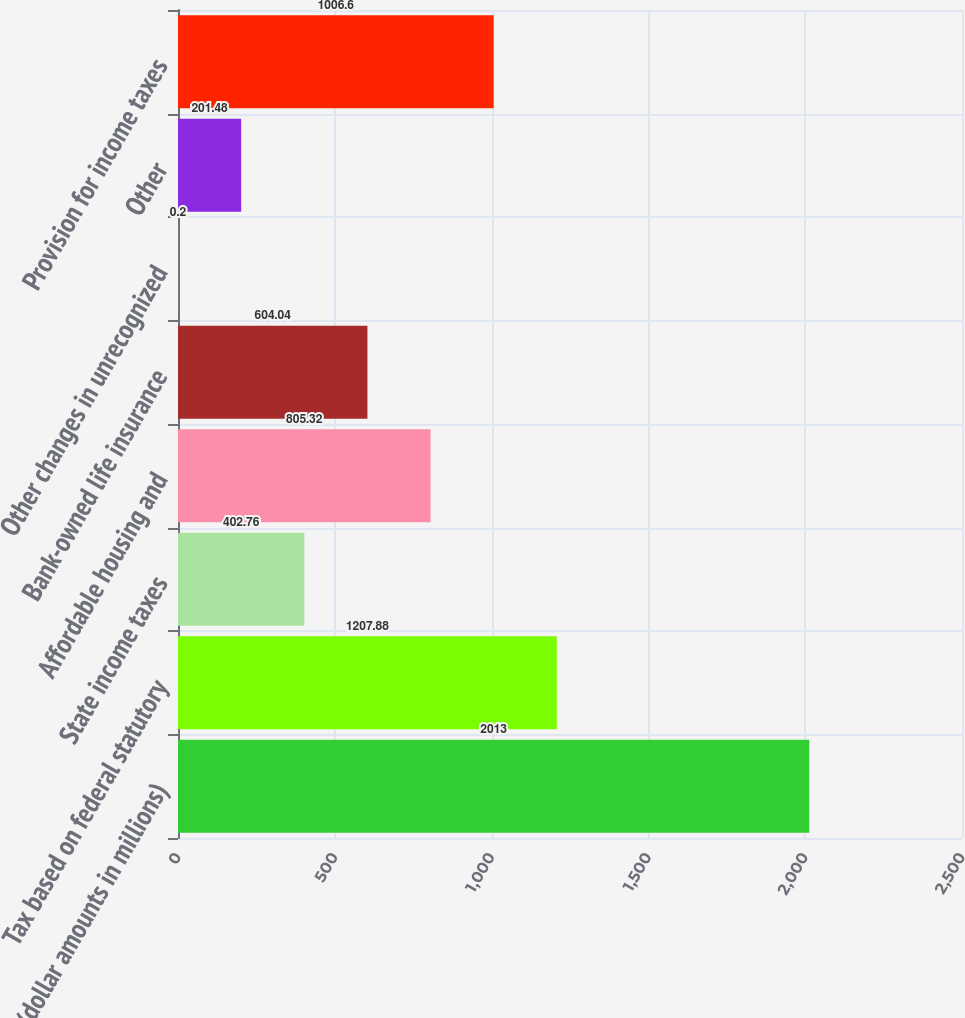Convert chart to OTSL. <chart><loc_0><loc_0><loc_500><loc_500><bar_chart><fcel>(dollar amounts in millions)<fcel>Tax based on federal statutory<fcel>State income taxes<fcel>Affordable housing and<fcel>Bank-owned life insurance<fcel>Other changes in unrecognized<fcel>Other<fcel>Provision for income taxes<nl><fcel>2013<fcel>1207.88<fcel>402.76<fcel>805.32<fcel>604.04<fcel>0.2<fcel>201.48<fcel>1006.6<nl></chart> 